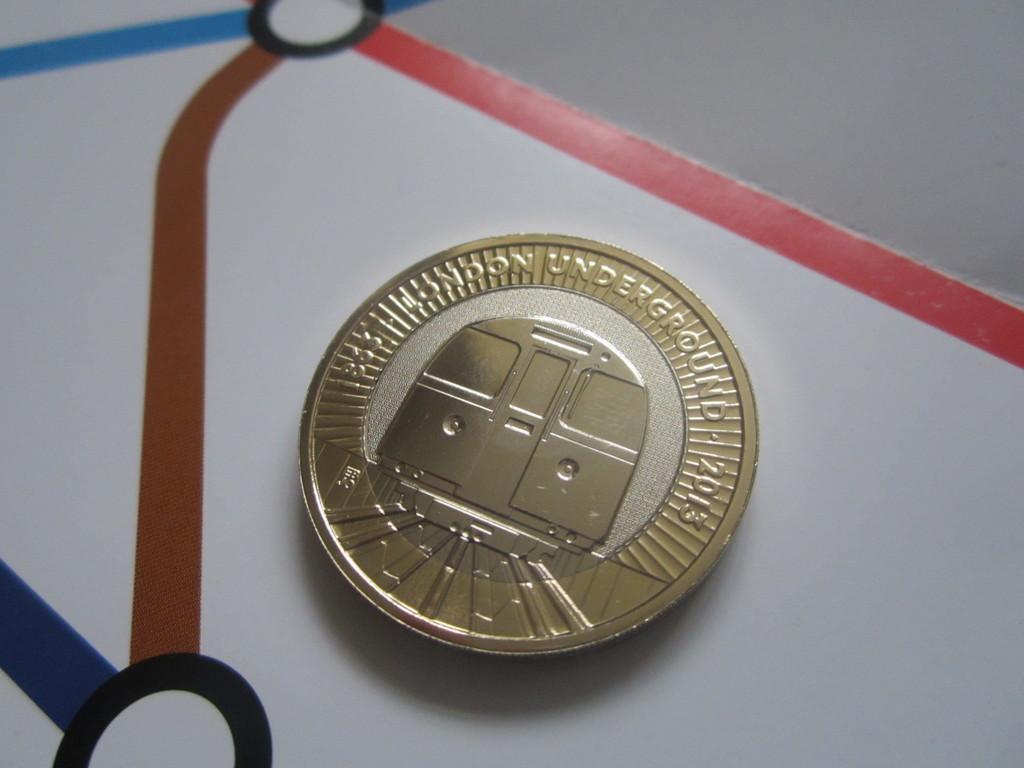Please provide a concise description of this image. In this image we can see a golden color coin on which it has been written London underground 2013. 